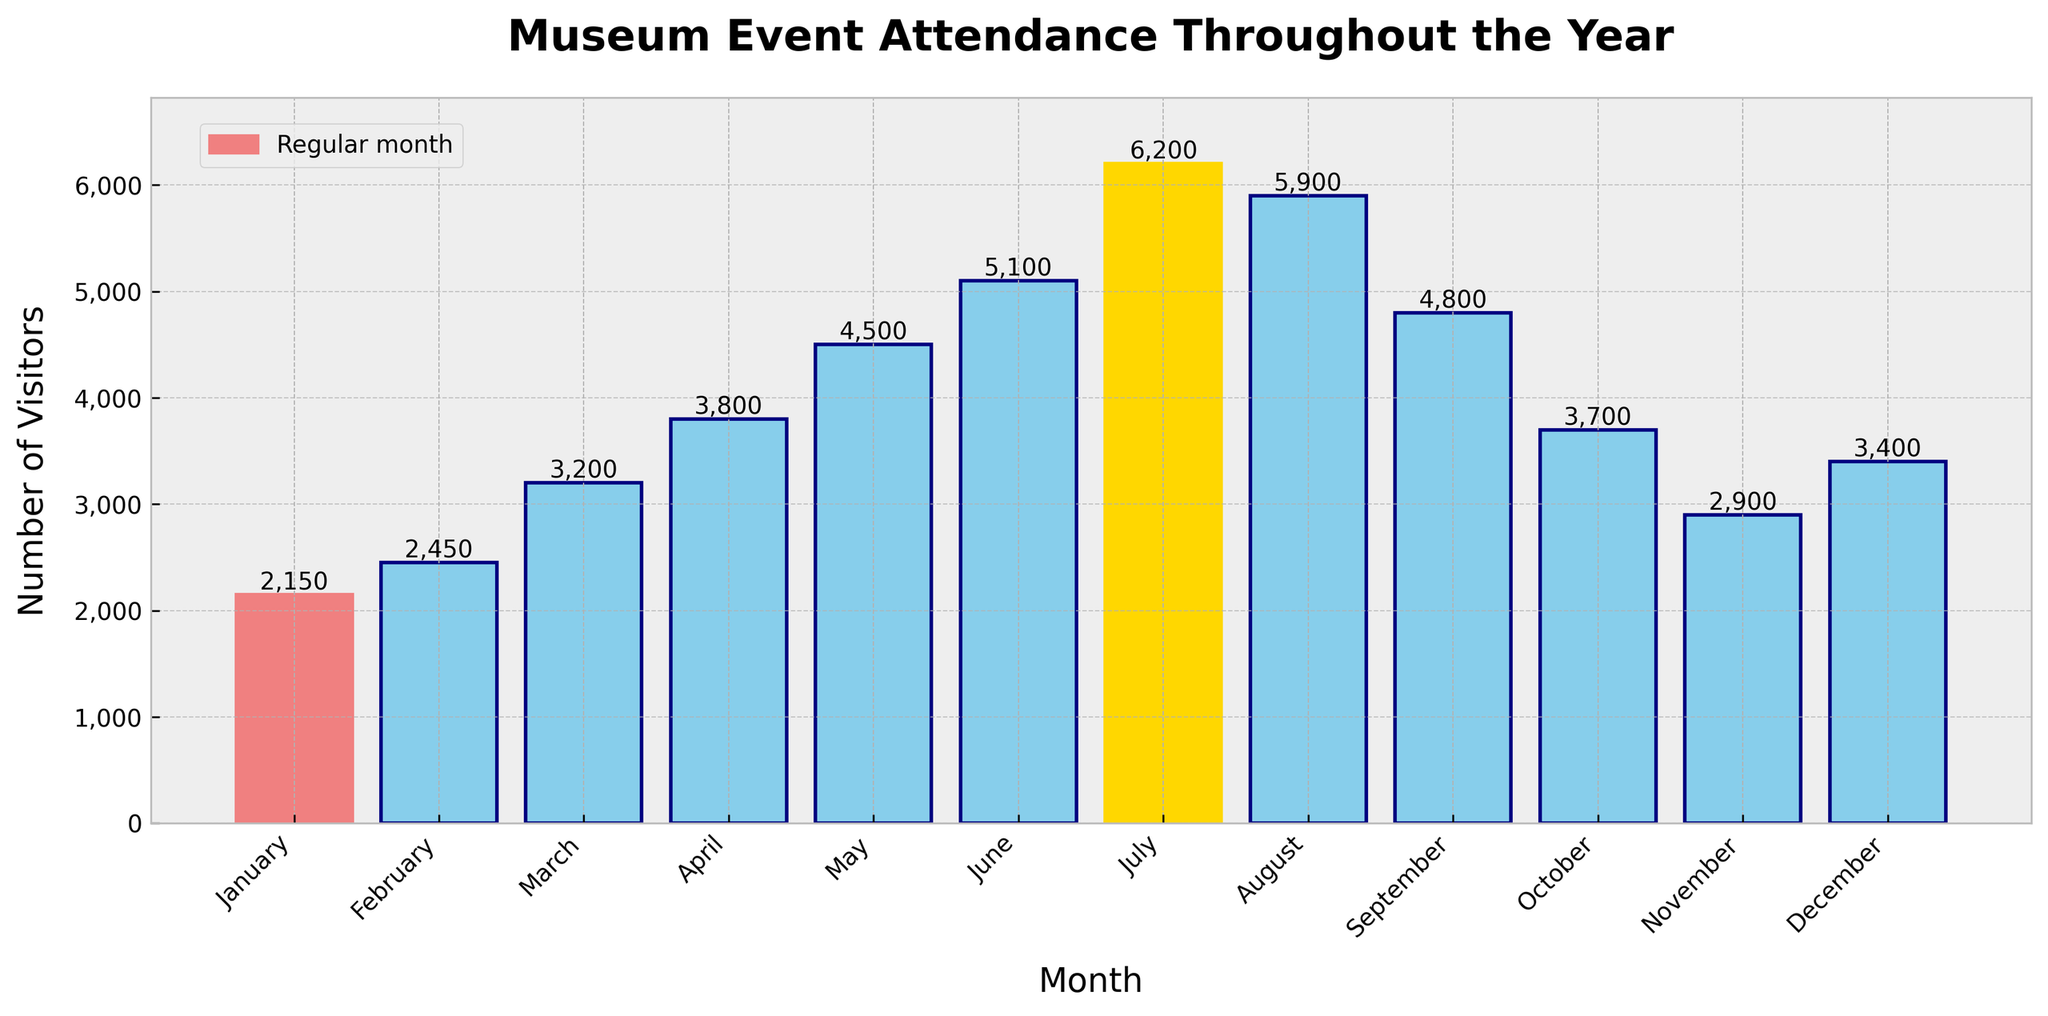Which month had the highest attendance? Observe the bar chart and identify the bar with the tallest height. The highest attendance is indicated by the gold-colored bar.
Answer: July Which month had the lowest attendance? Look at the bar chart for the shortest bar. The lowest attendance is represented by the light coral-colored bar.
Answer: January What is the total number of visitors in the first quarter (January, February, March)? Sum the number of visitors for January, February, and March: 2150 + 2450 + 3200 = 7800.
Answer: 7800 Compare the attendance of July and December. Which month had higher attendance and by how much? Look at the bars for July and December. July had 6200 visitors, and December had 3400. The difference is 6200 - 3400 = 2800.
Answer: July, by 2800 What is the average monthly attendance for the entire year? Sum the total attendance for all months and divide by 12: (2150 + 2450 + 3200 + 3800 + 4500 + 5100 + 6200 + 5900 + 4800 + 3700 + 2900 + 3400) / 12 = 4116.67.
Answer: 4117 Which months had an attendance greater than 5000? Check the bars that exceed the 5000 line on the chart. The months are June, July, and August.
Answer: June, July, August How much did the attendance increase from January to June? Subtract the number of visitors in January from those in June: 5100 - 2150 = 2950.
Answer: 2950 What is the median monthly attendance? List the visitor numbers in ascending order and find the middle value(s). The sorted list is: [2150, 2450, 2900, 3200, 3400, 3700, 3800, 4500, 4800, 5100, 5900, 6200]. The median is the average of the 6th and 7th values: (3700 + 3800) / 2 = 3750.
Answer: 3750 Which quarter had the highest total attendance, and what was the total? Sum the attendance for each quarter and compare:
1st Quarter (Jan-Mar): 2150 + 2450 + 3200 = 7800
2nd Quarter (Apr-Jun): 3800 + 4500 + 5100 = 13400
3rd Quarter (Jul-Sep): 6200 + 5900 + 4800 = 16900
4th Quarter (Oct-Dec): 3700 + 2900 + 3400 = 10000
The highest total attendance was in the 3rd Quarter.
Answer: 3rd Quarter, 16900 